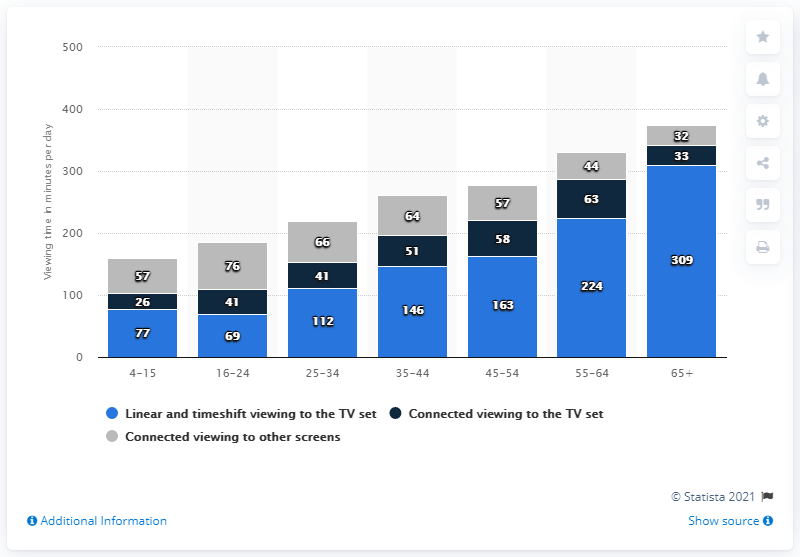Draw attention to some important aspects in this diagram. The median value of all the gray bars is 57. The bar chart uses three colors to represent the data. 